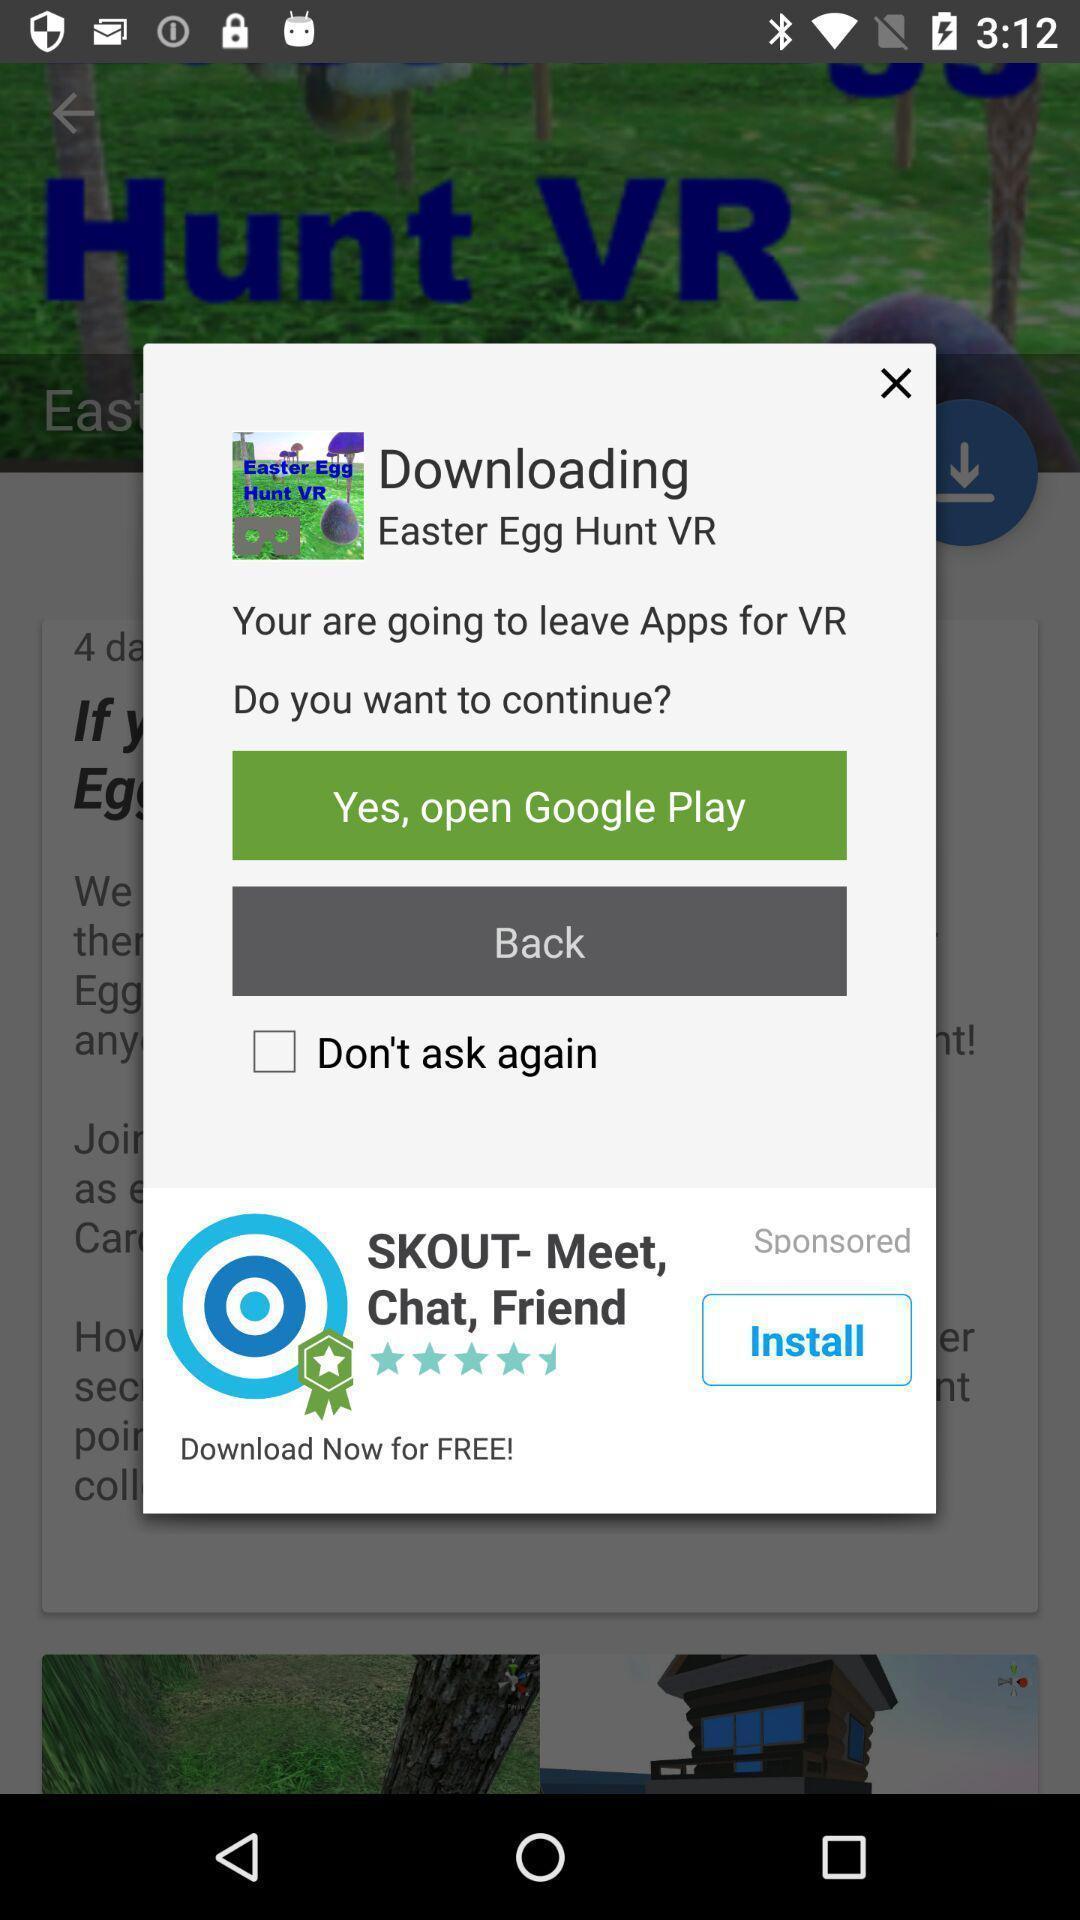Describe the visual elements of this screenshot. Pop-up displaying application to install. 